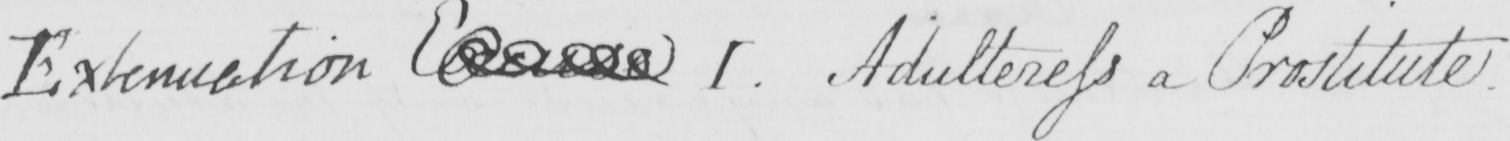Transcribe the text shown in this historical manuscript line. Extenuation Excuse I . Adulteress a Prostitute . 